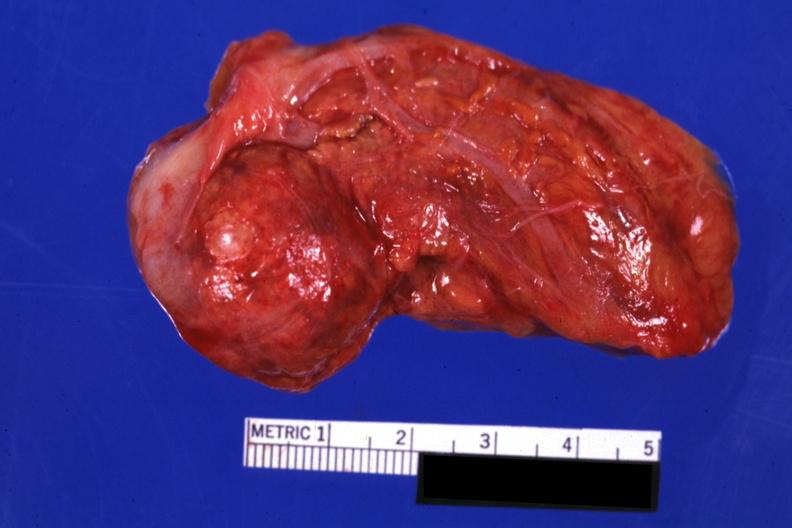what is present?
Answer the question using a single word or phrase. Endocrine 